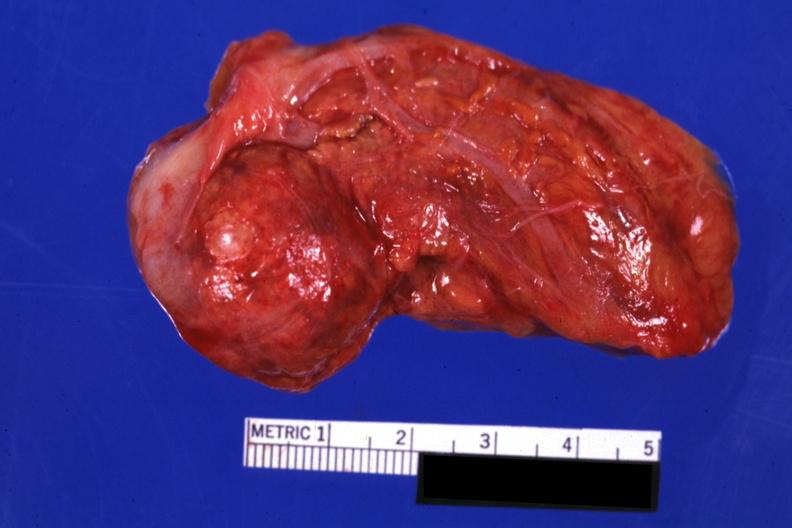what is present?
Answer the question using a single word or phrase. Endocrine 